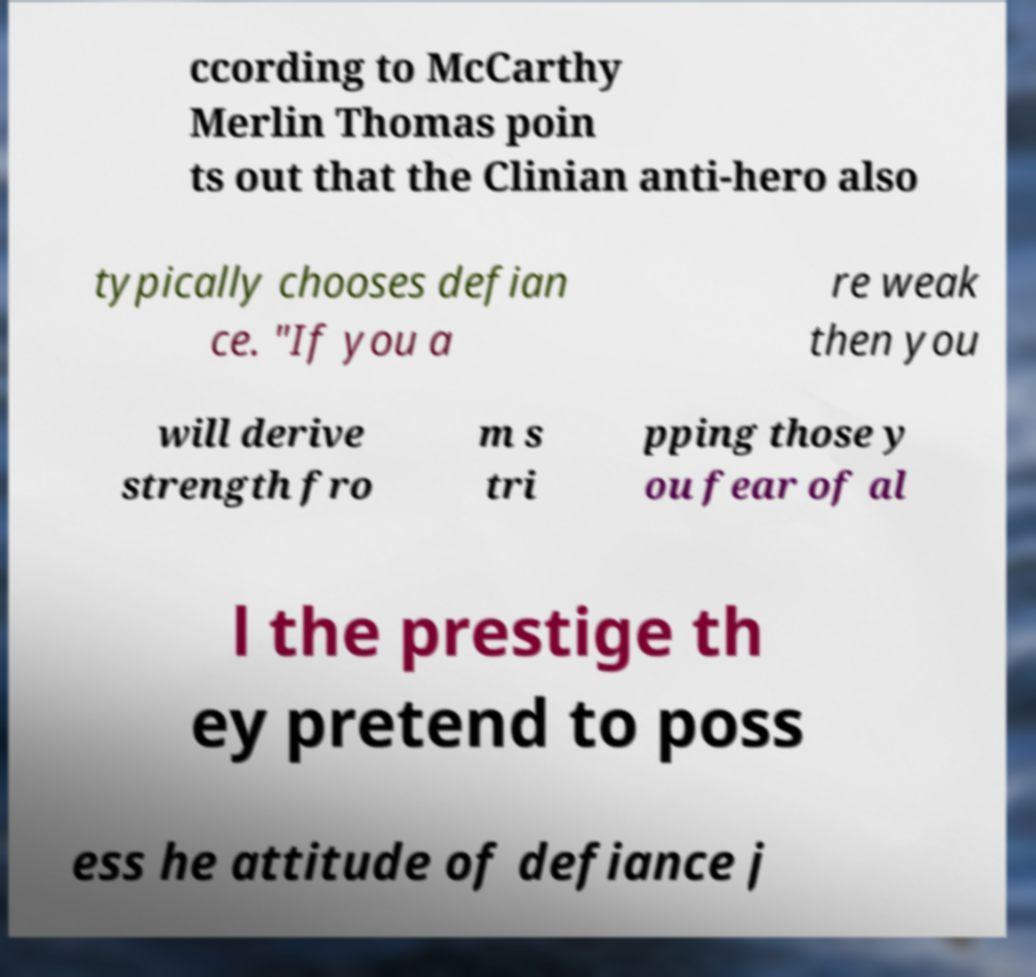I need the written content from this picture converted into text. Can you do that? ccording to McCarthy Merlin Thomas poin ts out that the Clinian anti-hero also typically chooses defian ce. "If you a re weak then you will derive strength fro m s tri pping those y ou fear of al l the prestige th ey pretend to poss ess he attitude of defiance j 